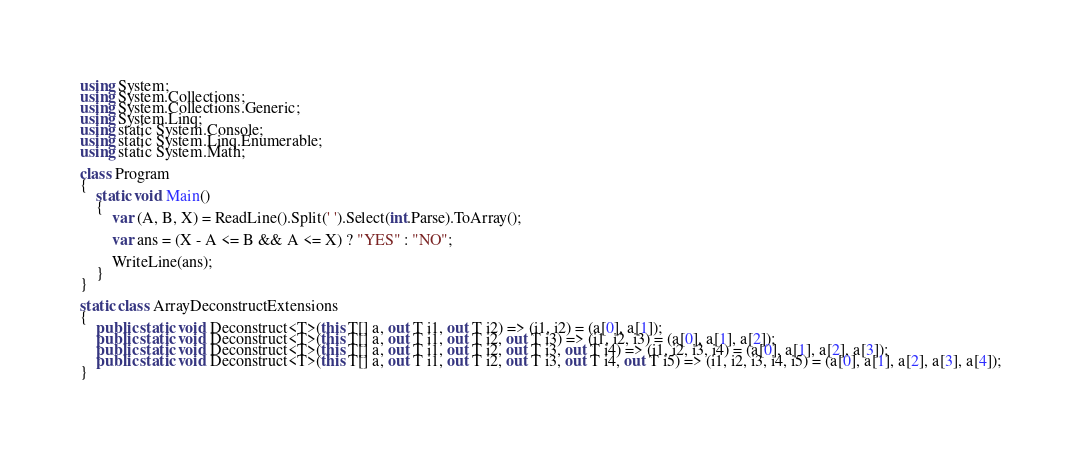<code> <loc_0><loc_0><loc_500><loc_500><_C#_>using System;
using System.Collections;
using System.Collections.Generic;
using System.Linq;
using static System.Console;
using static System.Linq.Enumerable;
using static System.Math;

class Program
{
    static void Main()
    {
        var (A, B, X) = ReadLine().Split(' ').Select(int.Parse).ToArray();

        var ans = (X - A <= B && A <= X) ? "YES" : "NO";

        WriteLine(ans);
    }
}

static class ArrayDeconstructExtensions
{
    public static void Deconstruct<T>(this T[] a, out T i1, out T i2) => (i1, i2) = (a[0], a[1]);
    public static void Deconstruct<T>(this T[] a, out T i1, out T i2, out T i3) => (i1, i2, i3) = (a[0], a[1], a[2]);
    public static void Deconstruct<T>(this T[] a, out T i1, out T i2, out T i3, out T i4) => (i1, i2, i3, i4) = (a[0], a[1], a[2], a[3]);
    public static void Deconstruct<T>(this T[] a, out T i1, out T i2, out T i3, out T i4, out T i5) => (i1, i2, i3, i4, i5) = (a[0], a[1], a[2], a[3], a[4]);
}
</code> 